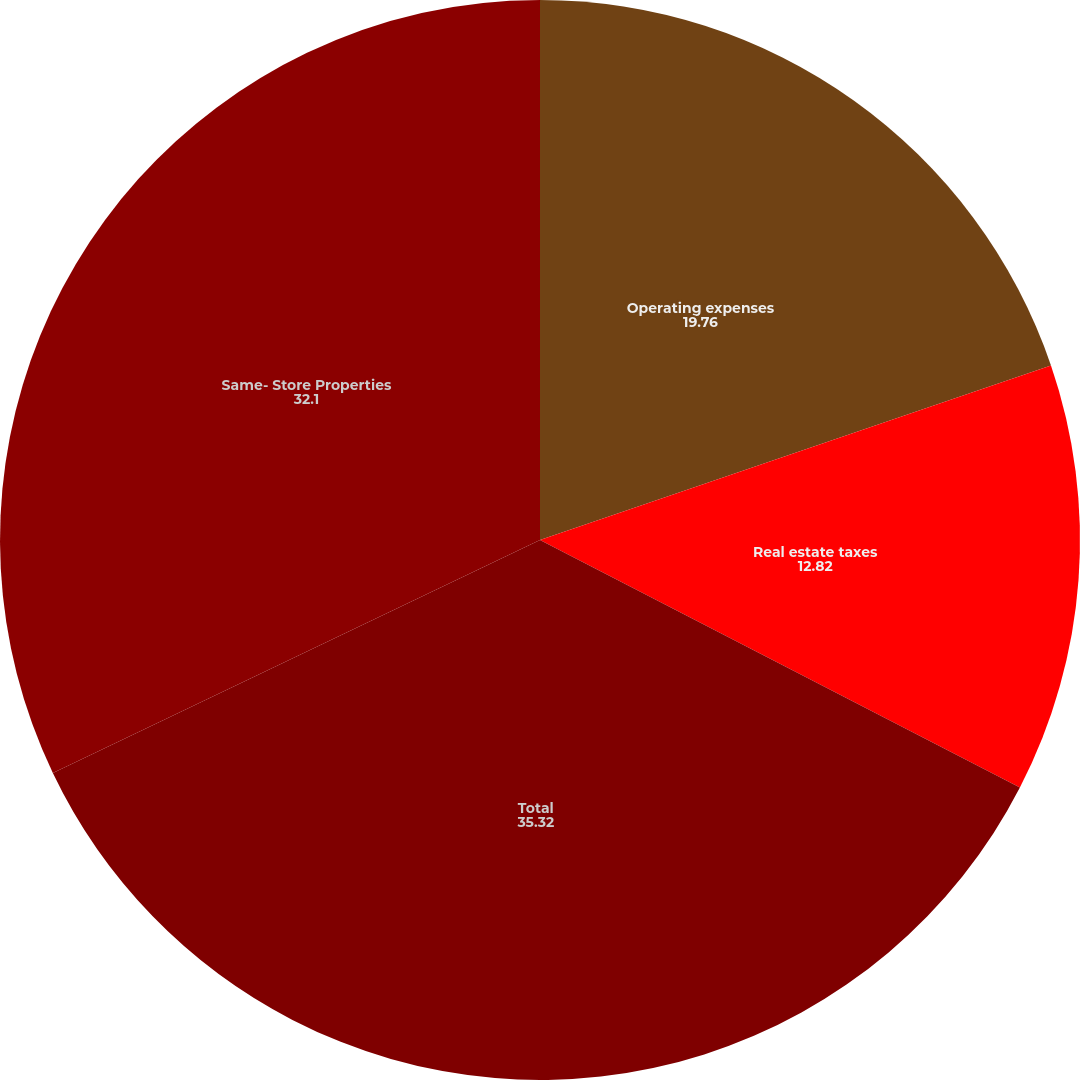Convert chart to OTSL. <chart><loc_0><loc_0><loc_500><loc_500><pie_chart><fcel>Operating expenses<fcel>Real estate taxes<fcel>Total<fcel>Same- Store Properties<nl><fcel>19.76%<fcel>12.82%<fcel>35.32%<fcel>32.1%<nl></chart> 